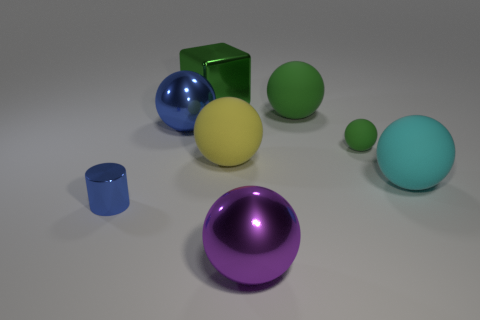Is there anything else that has the same shape as the tiny shiny object?
Keep it short and to the point. No. What number of objects are either purple metallic balls or big things?
Make the answer very short. 6. There is a blue ball; does it have the same size as the metallic sphere in front of the blue shiny sphere?
Your answer should be very brief. Yes. What color is the big object that is right of the small object that is behind the cylinder in front of the large green rubber thing?
Keep it short and to the point. Cyan. The block has what color?
Keep it short and to the point. Green. Is the number of yellow matte balls that are behind the big green sphere greater than the number of yellow things behind the large yellow object?
Your response must be concise. No. There is a green shiny thing; is it the same shape as the rubber thing left of the big purple metallic object?
Ensure brevity in your answer.  No. Do the green thing that is in front of the blue ball and the sphere right of the small matte ball have the same size?
Give a very brief answer. No. Is there a small green object to the left of the green metal block on the right side of the blue thing that is on the right side of the blue metal cylinder?
Ensure brevity in your answer.  No. Is the number of large green objects on the left side of the green metal cube less than the number of blue shiny cylinders that are on the right side of the small blue metallic cylinder?
Provide a short and direct response. No. 